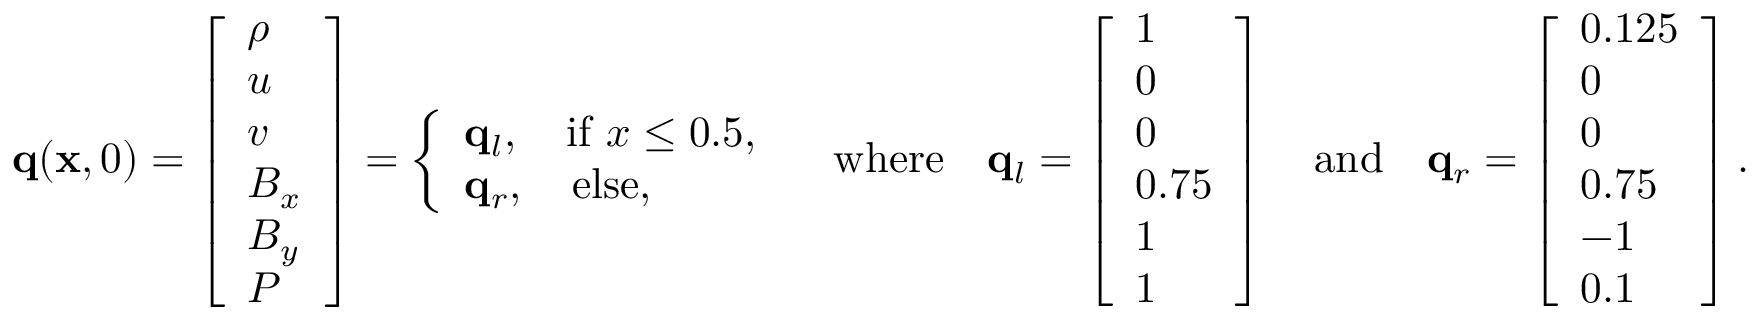Convert formula to latex. <formula><loc_0><loc_0><loc_500><loc_500>q ( x , 0 ) = \left [ \begin{array} { l } { \rho } \\ { u } \\ { v } \\ { B _ { x } } \\ { B _ { y } } \\ { P } \end{array} \right ] = \left \{ \begin{array} { l l } { q _ { l } , \quad i f \ x \leq 0 . 5 , } \\ { q _ { r } , \quad e l s e , } \end{array} \quad w h e r e \quad q _ { l } = \left [ \begin{array} { l } { 1 } \\ { 0 } \\ { 0 } \\ { 0 . 7 5 } \\ { 1 } \\ { 1 } \end{array} \right ] \quad a n d \quad q _ { r } = \left [ \begin{array} { l } { 0 . 1 2 5 } \\ { 0 } \\ { 0 } \\ { 0 . 7 5 } \\ { - 1 } \\ { 0 . 1 } \end{array} \right ] .</formula> 